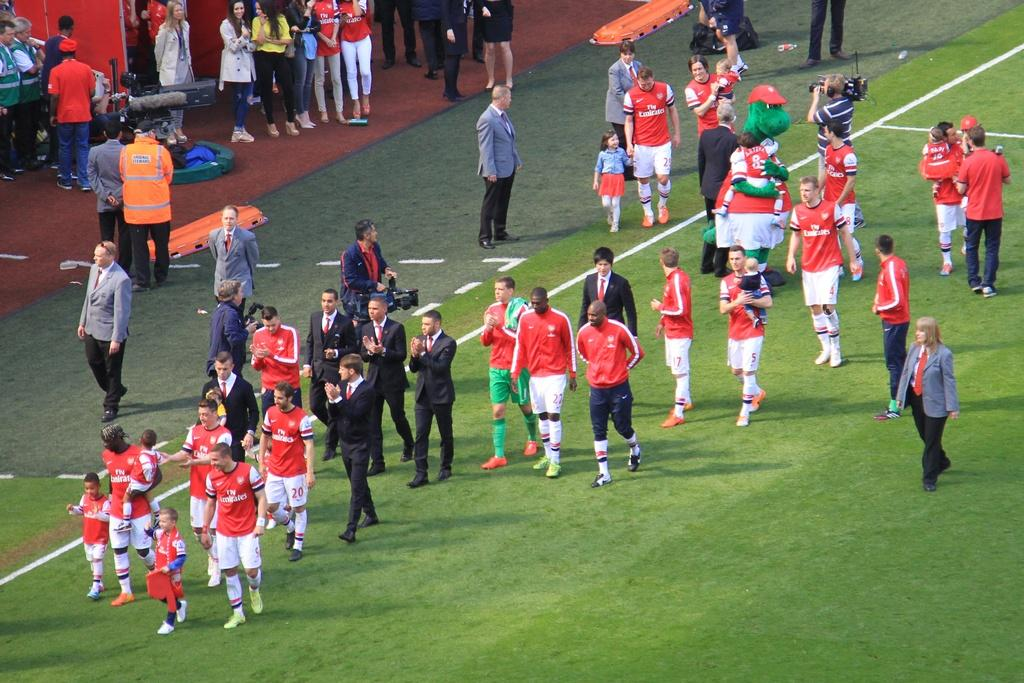<image>
Give a short and clear explanation of the subsequent image. A soccer player wearing a jersey with Fly Emirates on the front is walking with other players and holding the hand of a child. 